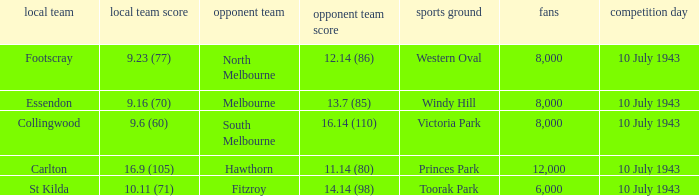When the Away team scored 14.14 (98), which Venue did the game take place? Toorak Park. 